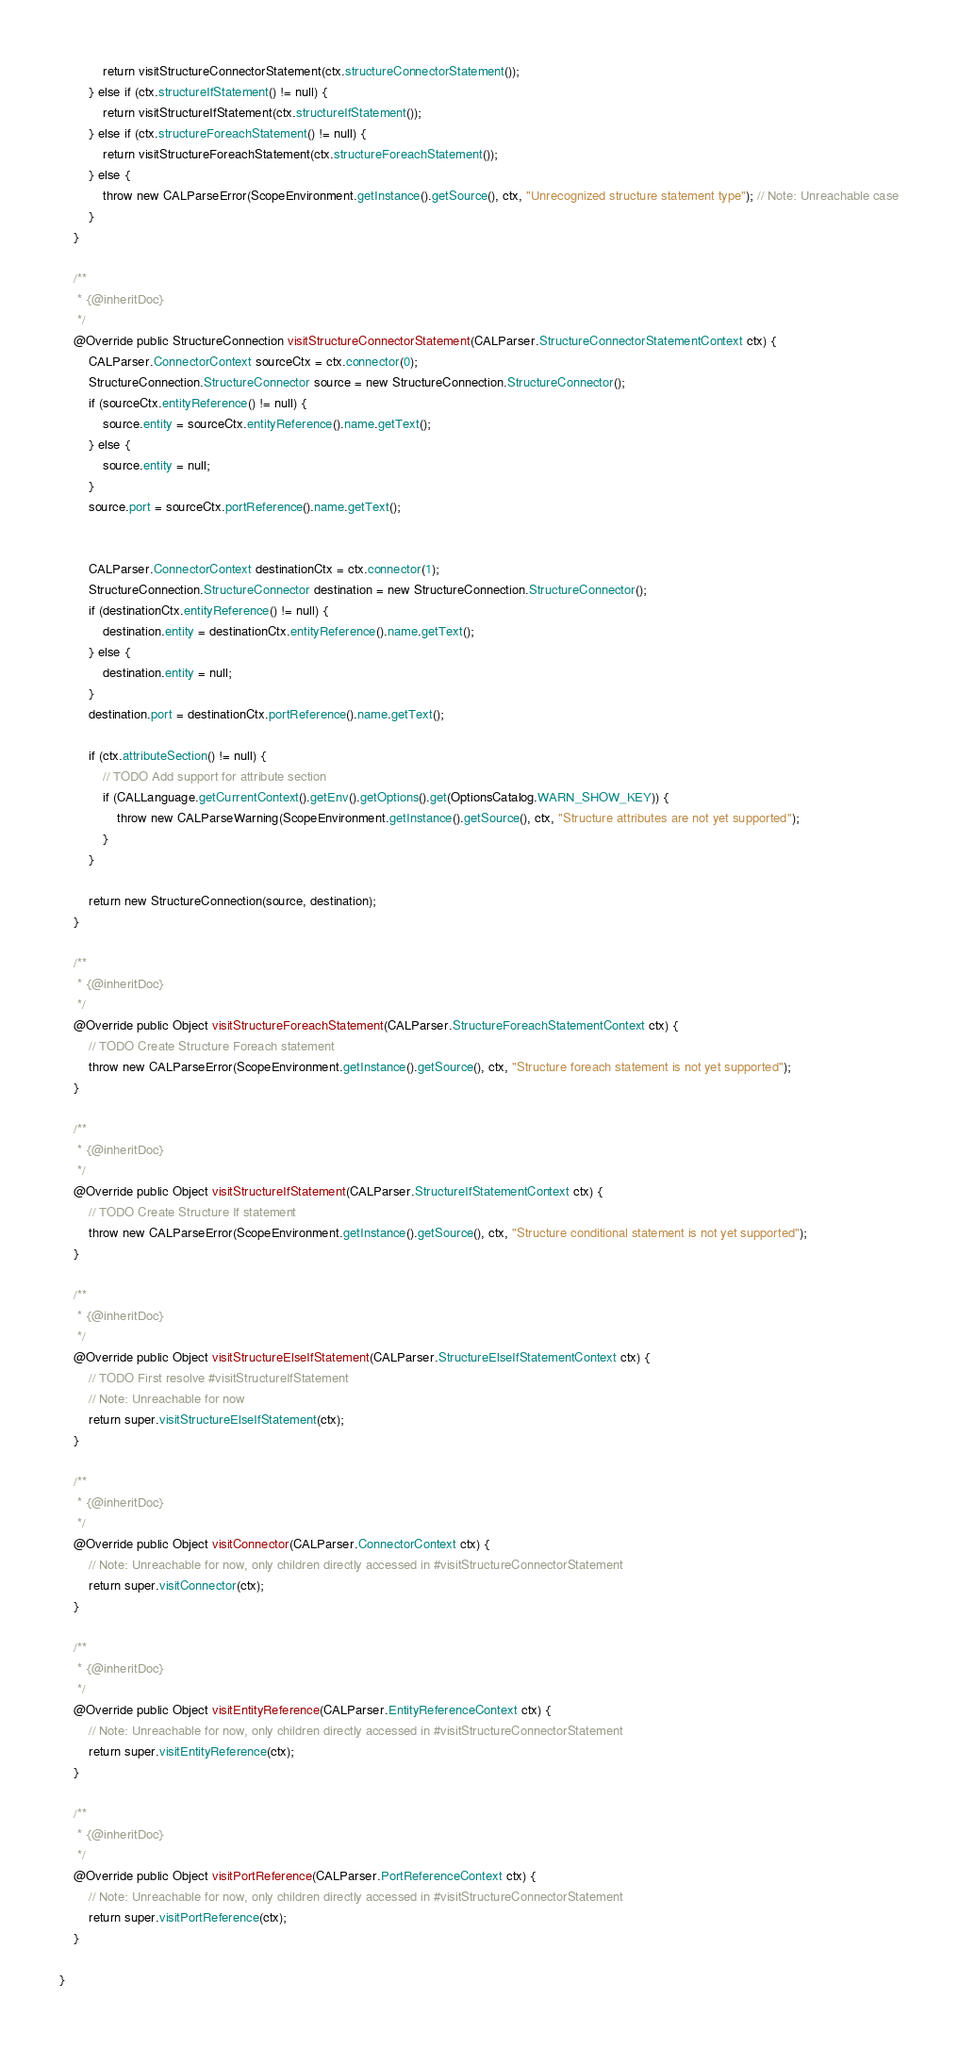<code> <loc_0><loc_0><loc_500><loc_500><_Java_>            return visitStructureConnectorStatement(ctx.structureConnectorStatement());
        } else if (ctx.structureIfStatement() != null) {
            return visitStructureIfStatement(ctx.structureIfStatement());
        } else if (ctx.structureForeachStatement() != null) {
            return visitStructureForeachStatement(ctx.structureForeachStatement());
        } else {
            throw new CALParseError(ScopeEnvironment.getInstance().getSource(), ctx, "Unrecognized structure statement type"); // Note: Unreachable case
        }
    }

    /**
     * {@inheritDoc}
     */
    @Override public StructureConnection visitStructureConnectorStatement(CALParser.StructureConnectorStatementContext ctx) {
        CALParser.ConnectorContext sourceCtx = ctx.connector(0);
        StructureConnection.StructureConnector source = new StructureConnection.StructureConnector();
        if (sourceCtx.entityReference() != null) {
            source.entity = sourceCtx.entityReference().name.getText();
        } else {
            source.entity = null;
        }
        source.port = sourceCtx.portReference().name.getText();


        CALParser.ConnectorContext destinationCtx = ctx.connector(1);
        StructureConnection.StructureConnector destination = new StructureConnection.StructureConnector();
        if (destinationCtx.entityReference() != null) {
            destination.entity = destinationCtx.entityReference().name.getText();
        } else {
            destination.entity = null;
        }
        destination.port = destinationCtx.portReference().name.getText();

        if (ctx.attributeSection() != null) {
            // TODO Add support for attribute section
            if (CALLanguage.getCurrentContext().getEnv().getOptions().get(OptionsCatalog.WARN_SHOW_KEY)) {
                throw new CALParseWarning(ScopeEnvironment.getInstance().getSource(), ctx, "Structure attributes are not yet supported");
            }
        }

        return new StructureConnection(source, destination);
    }

    /**
     * {@inheritDoc}
     */
    @Override public Object visitStructureForeachStatement(CALParser.StructureForeachStatementContext ctx) {
        // TODO Create Structure Foreach statement
        throw new CALParseError(ScopeEnvironment.getInstance().getSource(), ctx, "Structure foreach statement is not yet supported");
    }

    /**
     * {@inheritDoc}
     */
    @Override public Object visitStructureIfStatement(CALParser.StructureIfStatementContext ctx) {
        // TODO Create Structure If statement
        throw new CALParseError(ScopeEnvironment.getInstance().getSource(), ctx, "Structure conditional statement is not yet supported");
    }

    /**
     * {@inheritDoc}
     */
    @Override public Object visitStructureElseIfStatement(CALParser.StructureElseIfStatementContext ctx) {
        // TODO First resolve #visitStructureIfStatement
        // Note: Unreachable for now
        return super.visitStructureElseIfStatement(ctx);
    }

    /**
     * {@inheritDoc}
     */
    @Override public Object visitConnector(CALParser.ConnectorContext ctx) {
        // Note: Unreachable for now, only children directly accessed in #visitStructureConnectorStatement
        return super.visitConnector(ctx);
    }

    /**
     * {@inheritDoc}
     */
    @Override public Object visitEntityReference(CALParser.EntityReferenceContext ctx) {
        // Note: Unreachable for now, only children directly accessed in #visitStructureConnectorStatement
        return super.visitEntityReference(ctx);
    }

    /**
     * {@inheritDoc}
     */
    @Override public Object visitPortReference(CALParser.PortReferenceContext ctx) {
        // Note: Unreachable for now, only children directly accessed in #visitStructureConnectorStatement
        return super.visitPortReference(ctx);
    }

}</code> 